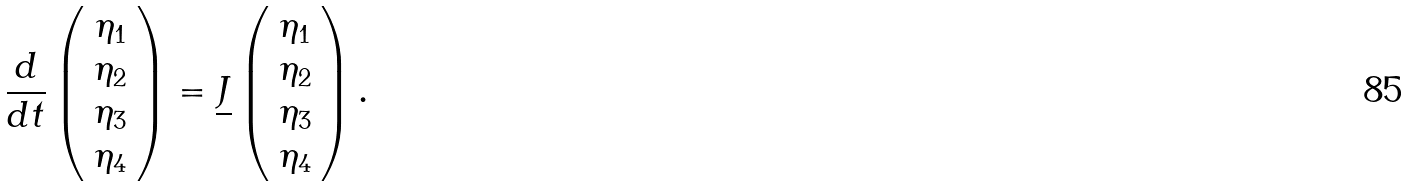Convert formula to latex. <formula><loc_0><loc_0><loc_500><loc_500>\frac { d } { d t } \left ( \begin{array} { c } \eta _ { 1 } \\ \eta _ { 2 } \\ \eta _ { 3 } \\ \eta _ { 4 } \end{array} \right ) = \underline { J } \left ( \begin{array} { l } \eta _ { 1 } \\ \eta _ { 2 } \\ \eta _ { 3 } \\ \eta _ { 4 } \end{array} \right ) .</formula> 